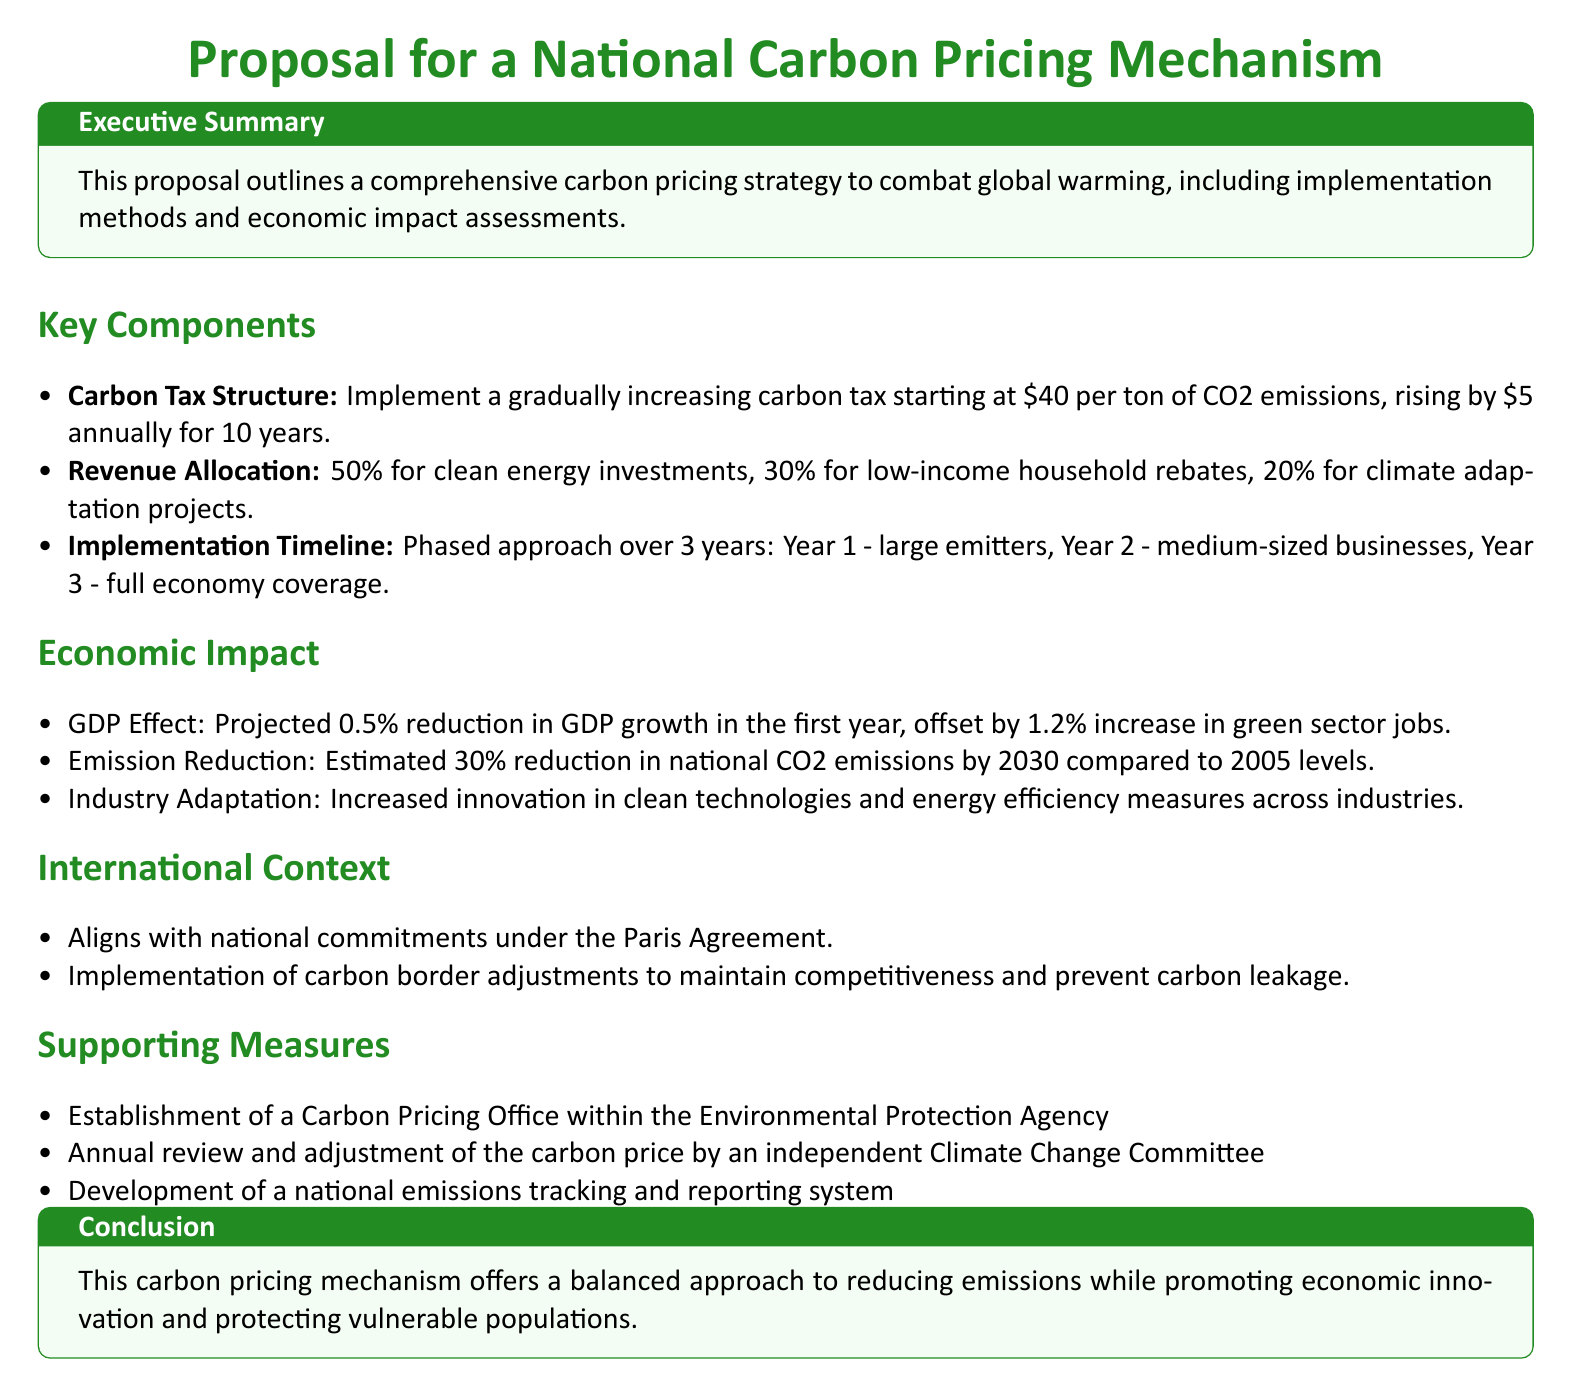What is the starting carbon tax rate? The document states that the carbon tax starts at $40 per ton of CO2 emissions.
Answer: $40 What percentage of revenue is allocated for clean energy investments? The document outlines that 50% of the revenue is allocated for clean energy investments.
Answer: 50% What is the projected reduction in national CO2 emissions by 2030? According to the document, the estimated reduction in national CO2 emissions is 30% by 2030 compared to 2005 levels.
Answer: 30% What is the implementation timeline duration? The document mentions a phased approach over 3 years for implementation.
Answer: 3 years Which office will establish the Carbon Pricing Office? The document specifies that the Carbon Pricing Office will be within the Environmental Protection Agency.
Answer: Environmental Protection Agency What is the projected impact on GDP growth in the first year? The document states there would be a 0.5% reduction in GDP growth in the first year.
Answer: 0.5% What motivates the use of carbon border adjustments? The document indicates they are to maintain competitiveness and prevent carbon leakage.
Answer: Maintain competitiveness What committee will review and adjust the carbon price? The document mentions an independent Climate Change Committee for this purpose.
Answer: Climate Change Committee Which international agreement does this proposal align with? The document states that the proposal aligns with the national commitments under the Paris Agreement.
Answer: Paris Agreement 